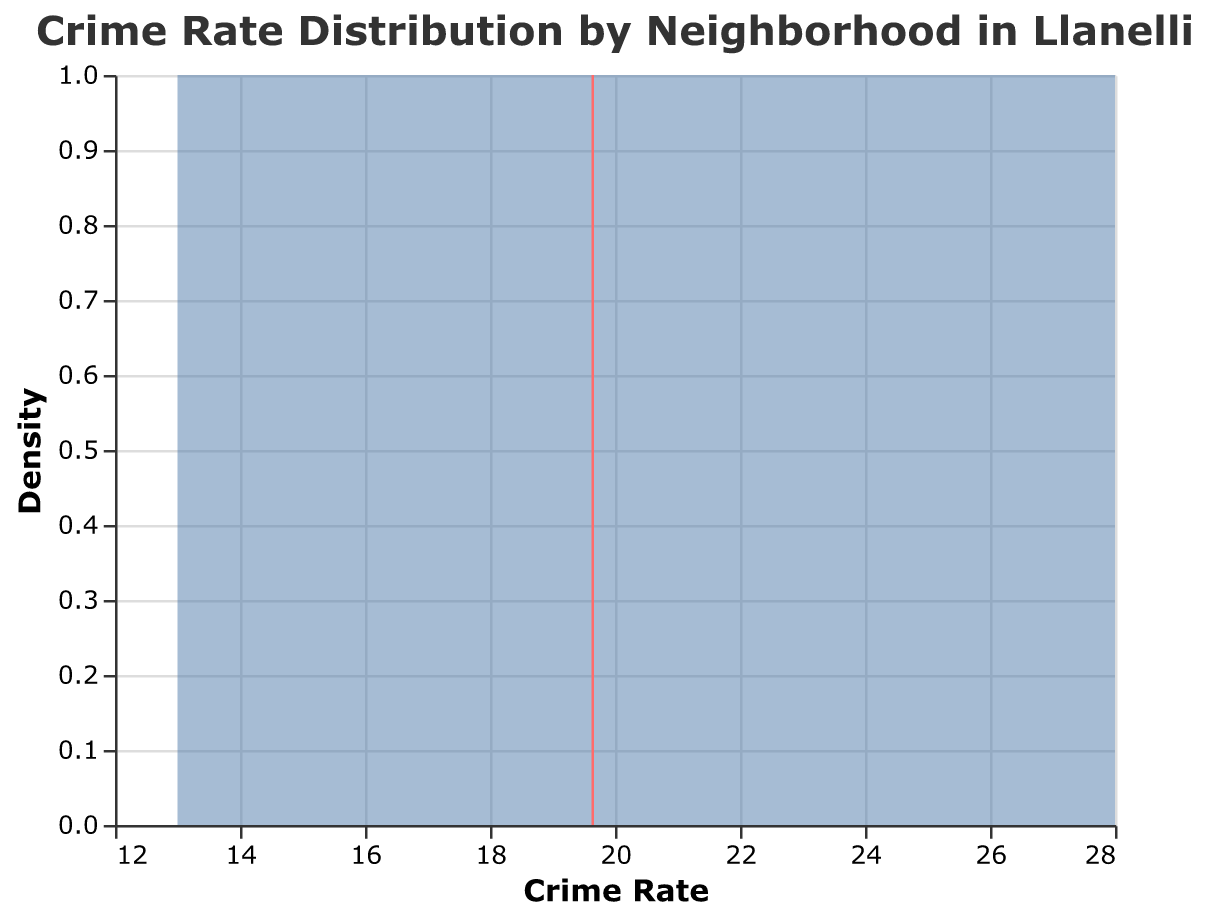What does the title of the plot indicate? The title of the plot provides an overview of what the visualization is about, which is essential for understanding the context.
Answer: Crime Rate Distribution by Neighborhood in Llanelli How many neighborhoods are included in the plot? The plot includes data points representing various neighborhoods, which can be counted using the given data or plot.
Answer: 14 Which neighborhood has the highest crime rate? The plot shows the distribution of crime rates for different neighborhoods. The neighborhood with the highest position on the x-axis has the highest crime rate. By looking at the data plot, Tyisha has the highest crime rate.
Answer: Tyisha What is the mean crime rate across all neighborhoods? A vertical line on the plot indicates the mean value of the crime rates. By observing this line’s position on the x-axis, we can infer the mean crime rate.
Answer: 20.14 (approx.) Which neighborhoods have crime rates above the mean? By determining the neighborhoods plotted to the right of the mean vertical line, one can list those with crime rates above the mean.
Answer: Felinfoel, Llwynhendy, Morfa, Tyisha, Trostre How does the crime rate in Swiss Valley compare to that in Furnace? By examining the data points in the plot, Swiss Valley’s crime rate is 13 and Furnace’s is 14. Thus, Swiss Valley has a slightly lower crime rate than Furnace.
Answer: Furnace is higher Are there more neighborhoods with a crime rate below or above 20? Count the data points on either side of the 20 crime rate mark. Six neighborhoods (Brynmill, Dafen, Furnace, Hengoed, Llangennech, Sandy, Swiss Valley) have a crime rate below 20, and five (Felinfoel, Llwynhendy, Morfa, Tyisha, Trostre) above 20, excluding those exactly on 20.
Answer: Below 20 What is the density of neighborhoods with a crime rate of 16 to 20? By analyzing the height of the density plot within the range of 16 to 20 on the x-axis, we can infer the density at that segment. The height indicates the number of neighborhoods within that range is relatively higher.
Answer: Relatively high Which areas have exceptionally high or low crime rates? Exceptionally high and low values are indicated by the extreme ends of the plot. Tyisha has the highest at 28, and Swiss Valley has the lowest at 13.
Answer: Tyisha (high) and Swiss Valley (low) What trend does the density plot reveal about crime rates in Llanelli? The trend shown by the density plot highlights how crime rates are distributed across the neighborhoods. Most neighborhoods cluster around the mean crime rate, with a few outliers at both the high and low ends.
Answer: Most neighborhoods have crime rates around the mean 